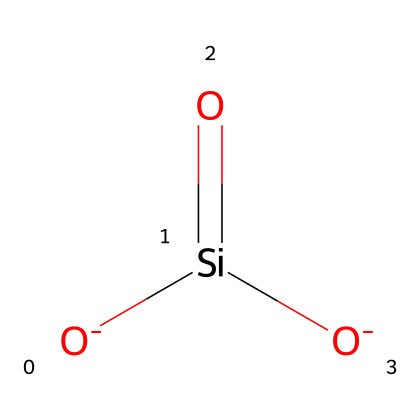What is the name of the chemical represented in the SMILES? The SMILES notation describes silicon dioxide, which is commonly known as silica. The presence of silicon (Si) and oxygen (O) atoms in the structure confirms this.
Answer: silica How many silicon atoms are in the structure? The SMILES notation indicates there is one silicon atom present, as evidenced by the notation [Si] in the structure.
Answer: 1 What is the total number of oxygen atoms in this molecule? The structure indicates there are two oxygen atoms which can be seen in the notation [O-][O-].
Answer: 2 What type of bonding exists between the silicon and oxygen atoms? The SMILES shows that silicon is double-bonded to one oxygen atom and single-bonded to the others, indicating a combination of double and single bonds due to the valency of Si and the connection with O.
Answer: covalent Why is silicon dioxide used in making fabrics stain-resistant? Silicon dioxide has a high surface area at the nanoscale, which allows it to interact effectively with water molecules and stain materials, enhancing the hydrophobic properties of the fabric.
Answer: hydrophobic What is the charge of the oxygen atoms in this molecule? The notation [O-] indicates that the oxygen atoms have a negative charge, which can influence their interaction with other materials and their role in the nanoparticle structure.
Answer: negative How does the molecular structure of silica contribute to its stability in fabric applications? The strong covalent bonding between silicon and oxygen ensures a stable structure, making silica durable and resistant to degradation under various environmental conditions, which is essential for fabric longevity.
Answer: strong covalent bonds 